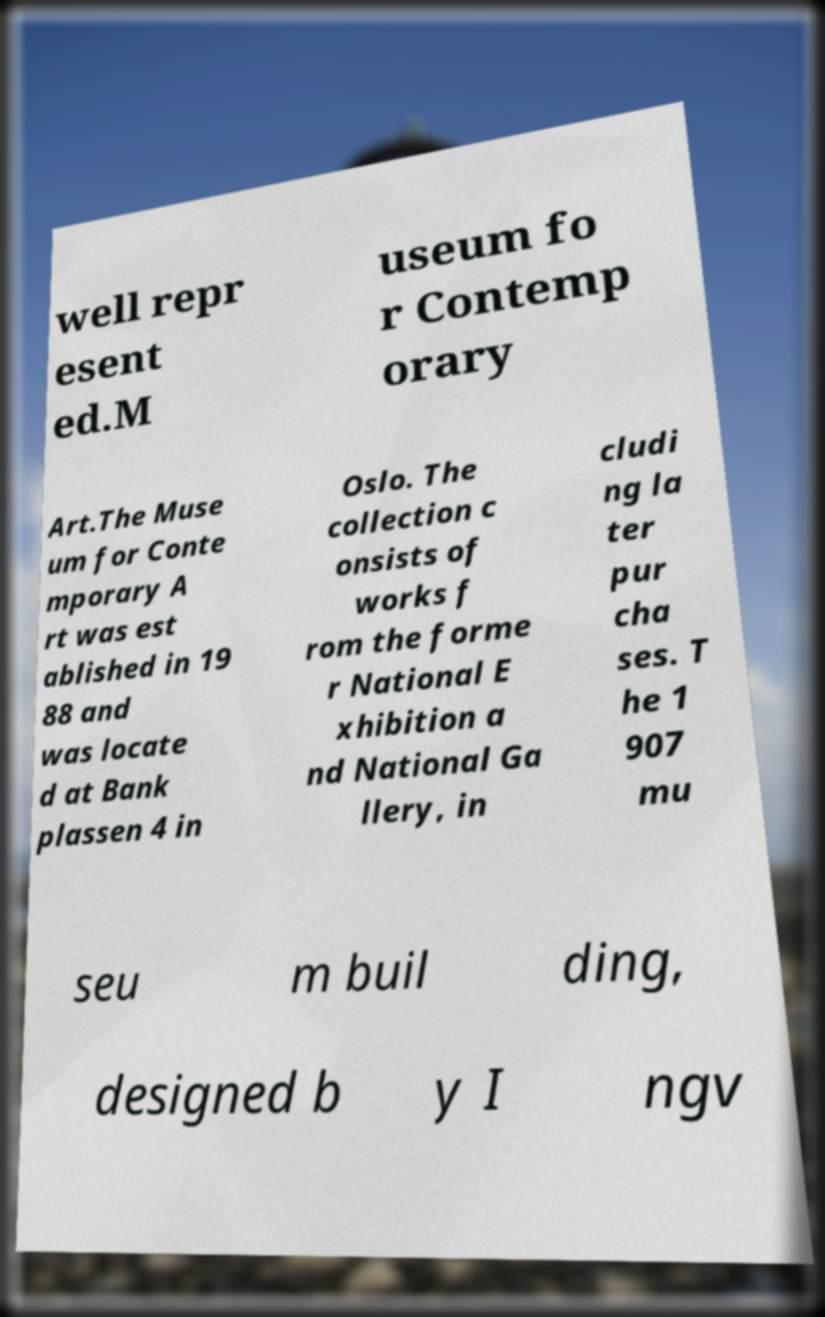Please identify and transcribe the text found in this image. well repr esent ed.M useum fo r Contemp orary Art.The Muse um for Conte mporary A rt was est ablished in 19 88 and was locate d at Bank plassen 4 in Oslo. The collection c onsists of works f rom the forme r National E xhibition a nd National Ga llery, in cludi ng la ter pur cha ses. T he 1 907 mu seu m buil ding, designed b y I ngv 